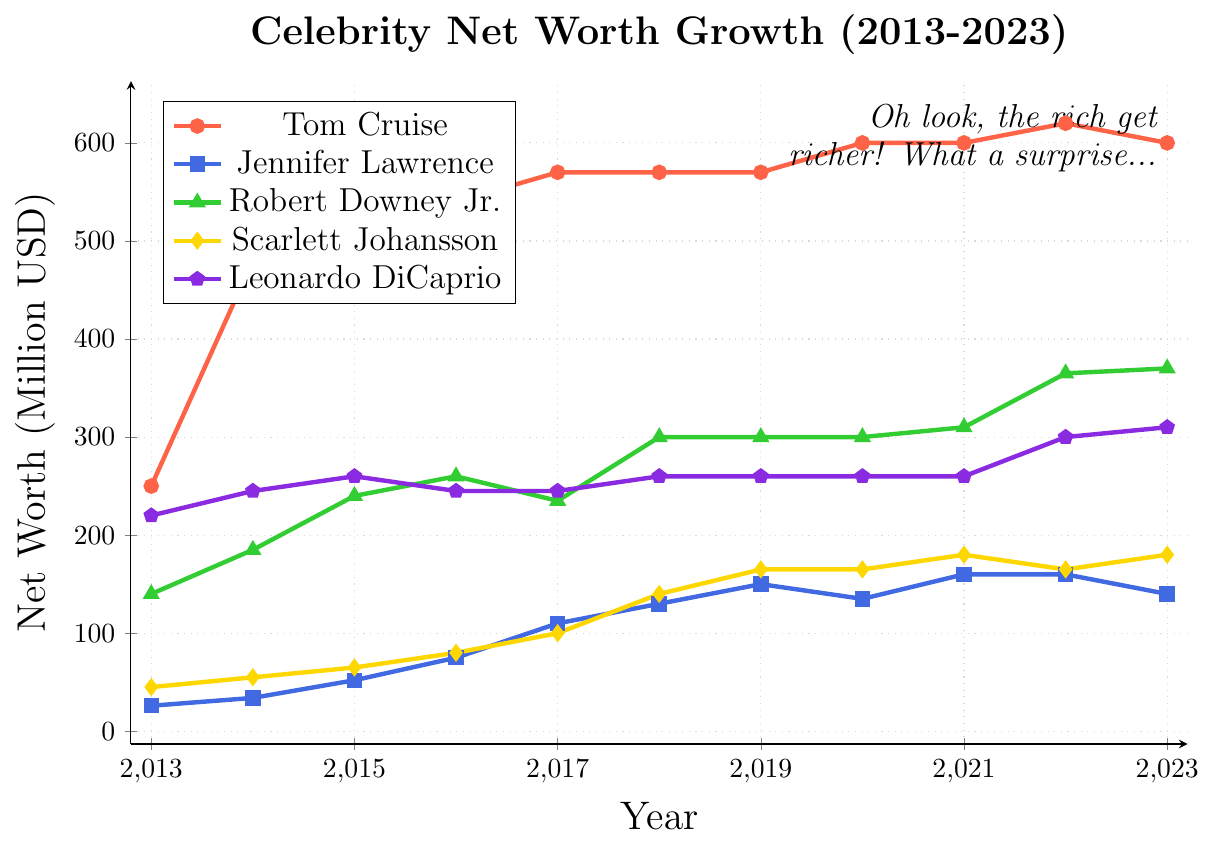What year did Robert Downey Jr.'s net worth surpass 300 million USD? According to the graph, Robert Downey Jr.'s net worth surpassed 300 million USD in the year 2018. This is the first year where the green line representing him is above 300 million.
Answer: 2018 Who had the highest net worth in 2023? The graph shows the highest data point for the year 2023 by checking the endpoints. Tom Cruise, represented by the red line, had the highest net worth among the actors in 2023, which is 600 million USD.
Answer: Tom Cruise Between which consecutive years did Tom Cruise's net worth increase the most? To determine this, observe the difference between consecutive years on the red line representing Tom Cruise. The largest increase is from 2013 to 2014, where his net worth jumped from 250 to 480 million USD, an increase of 230 million.
Answer: 2013-2014 Compare the net worth of Jennifer Lawrence in 2016 and Scarlett Johansson in 2016. Who has more? Jennifer Lawrence's net worth in 2016 is represented by the blue line and is 75 million USD. Scarlett Johansson's net worth is represented by the yellow line and is 80 million USD. Scarlett Johansson has more.
Answer: Scarlett Johansson What is the average net worth of Leonardo DiCaprio over the decade? To calculate the average, sum Leonardo DiCaprio's net worth for each year from 2013 to 2023 and divide by 11. (220 + 245 + 260 + 245 + 245 + 260 + 260 + 260 + 260 + 300 + 310) / 11 = 262.27 million USD.
Answer: 262.27 million USD In which year did Jennifer Lawrence experience a decrease in net worth? Looking at the blue line, it shows a drop from 150 million in 2019 to 135 million in 2020, and from 160 million in 2022 to 140 million in 2023. Thus, the years she experienced a decrease are 2020 and 2023.
Answer: 2020, 2023 How many years does Scarlett Johansson's net worth remain constant? Scarlett Johansson's net worth, represented by the yellow line, remains the same (165 million USD) from 2019 to 2020, and from 2022 to 2023. Therefore, it remains constant for 2 years.
Answer: 2 years What's the difference between the highest and lowest net worth of Tom Cruise over the decade? To find this difference, subtract the lowest net worth of Tom Cruise (2013, 250 million USD) from the highest (2022, 620 million USD). 620 - 250 = 370 million USD.
Answer: 370 million USD 